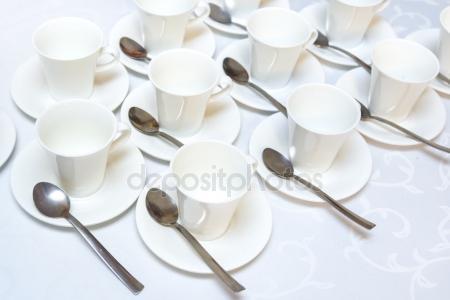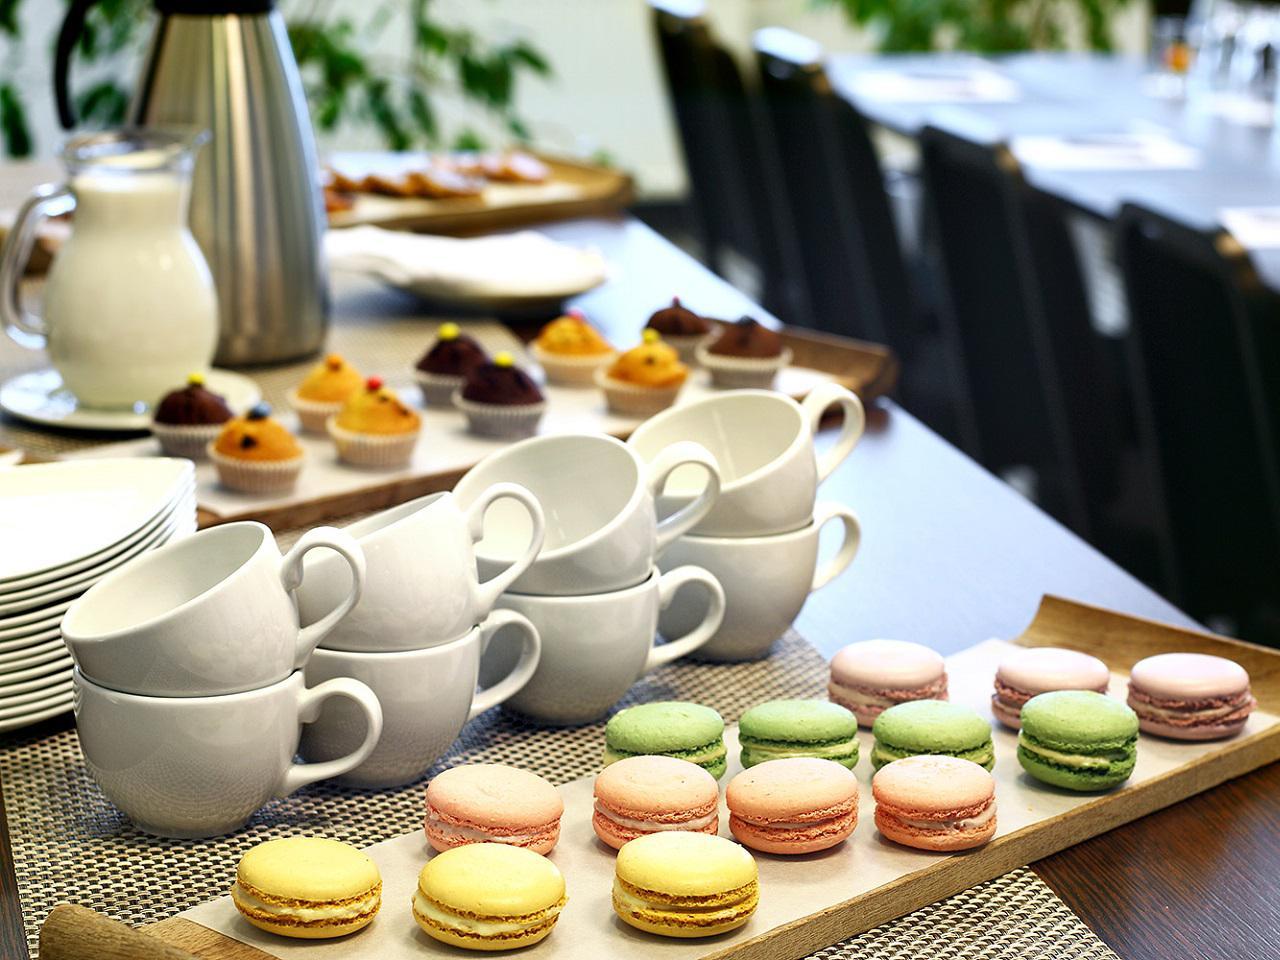The first image is the image on the left, the second image is the image on the right. Considering the images on both sides, is "At least one of the cups contains a beverage." valid? Answer yes or no. No. The first image is the image on the left, the second image is the image on the right. Evaluate the accuracy of this statement regarding the images: "The right image includes at least some rows of white coffee cups on white saucers that are not stacked on top of another white cup on a saucer.". Is it true? Answer yes or no. No. 